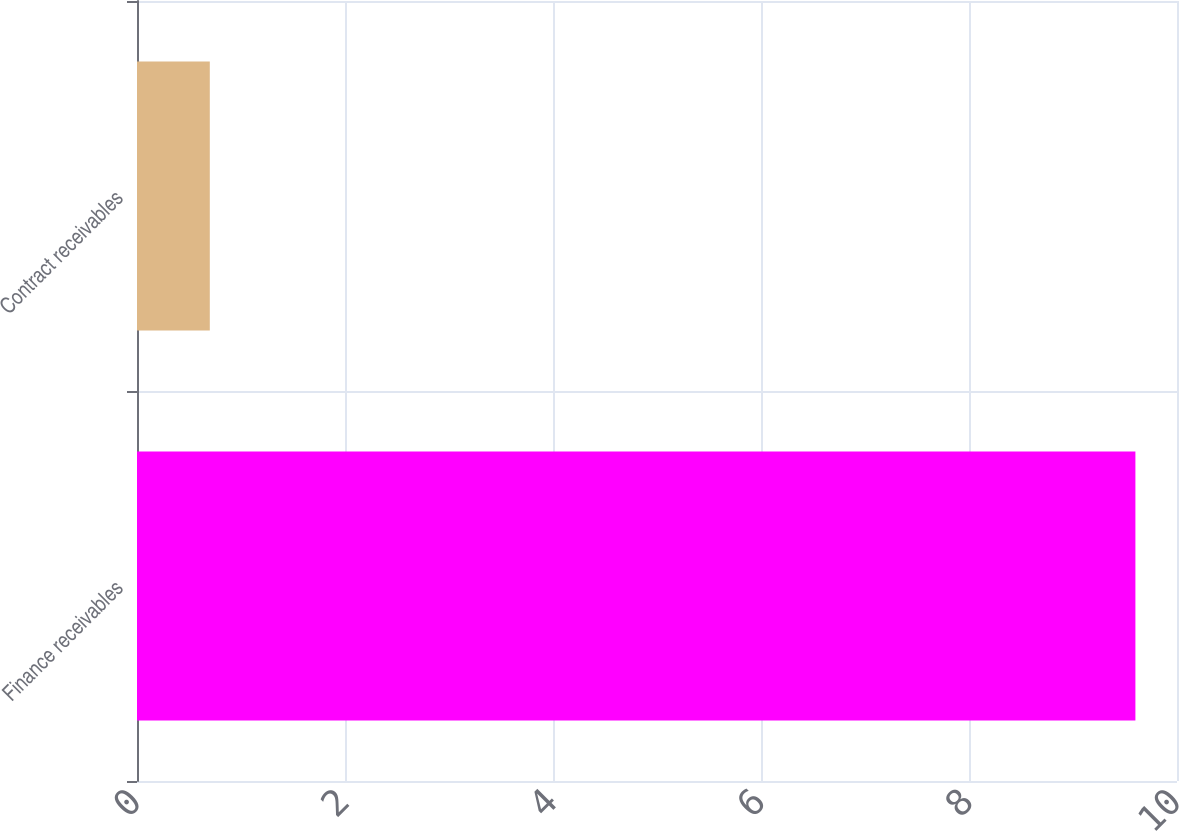Convert chart to OTSL. <chart><loc_0><loc_0><loc_500><loc_500><bar_chart><fcel>Finance receivables<fcel>Contract receivables<nl><fcel>9.6<fcel>0.7<nl></chart> 